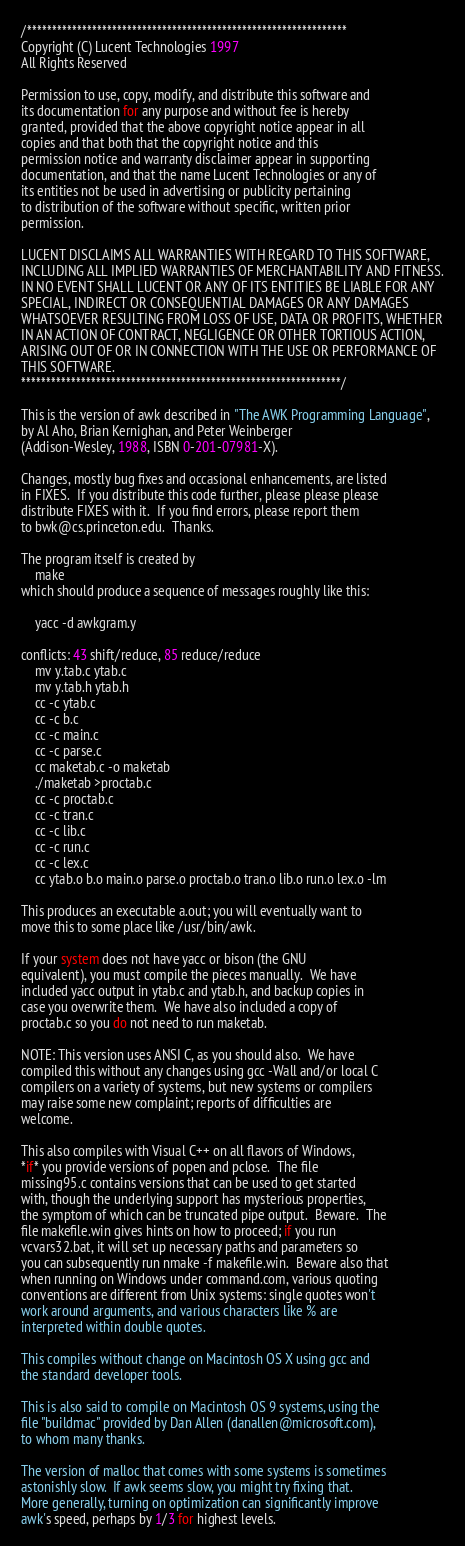<code> <loc_0><loc_0><loc_500><loc_500><_Awk_>/****************************************************************
Copyright (C) Lucent Technologies 1997
All Rights Reserved

Permission to use, copy, modify, and distribute this software and
its documentation for any purpose and without fee is hereby
granted, provided that the above copyright notice appear in all
copies and that both that the copyright notice and this
permission notice and warranty disclaimer appear in supporting
documentation, and that the name Lucent Technologies or any of
its entities not be used in advertising or publicity pertaining
to distribution of the software without specific, written prior
permission.

LUCENT DISCLAIMS ALL WARRANTIES WITH REGARD TO THIS SOFTWARE,
INCLUDING ALL IMPLIED WARRANTIES OF MERCHANTABILITY AND FITNESS.
IN NO EVENT SHALL LUCENT OR ANY OF ITS ENTITIES BE LIABLE FOR ANY
SPECIAL, INDIRECT OR CONSEQUENTIAL DAMAGES OR ANY DAMAGES
WHATSOEVER RESULTING FROM LOSS OF USE, DATA OR PROFITS, WHETHER
IN AN ACTION OF CONTRACT, NEGLIGENCE OR OTHER TORTIOUS ACTION,
ARISING OUT OF OR IN CONNECTION WITH THE USE OR PERFORMANCE OF
THIS SOFTWARE.
****************************************************************/

This is the version of awk described in "The AWK Programming Language",
by Al Aho, Brian Kernighan, and Peter Weinberger
(Addison-Wesley, 1988, ISBN 0-201-07981-X).

Changes, mostly bug fixes and occasional enhancements, are listed
in FIXES.  If you distribute this code further, please please please
distribute FIXES with it.  If you find errors, please report them
to bwk@cs.princeton.edu.  Thanks.

The program itself is created by
	make
which should produce a sequence of messages roughly like this:

	yacc -d awkgram.y

conflicts: 43 shift/reduce, 85 reduce/reduce
	mv y.tab.c ytab.c
	mv y.tab.h ytab.h
	cc -c ytab.c
	cc -c b.c
	cc -c main.c
	cc -c parse.c
	cc maketab.c -o maketab
	./maketab >proctab.c
	cc -c proctab.c
	cc -c tran.c
	cc -c lib.c
	cc -c run.c
	cc -c lex.c
	cc ytab.o b.o main.o parse.o proctab.o tran.o lib.o run.o lex.o -lm

This produces an executable a.out; you will eventually want to
move this to some place like /usr/bin/awk.

If your system does not have yacc or bison (the GNU
equivalent), you must compile the pieces manually.  We have
included yacc output in ytab.c and ytab.h, and backup copies in
case you overwrite them.  We have also included a copy of
proctab.c so you do not need to run maketab.

NOTE: This version uses ANSI C, as you should also.  We have
compiled this without any changes using gcc -Wall and/or local C
compilers on a variety of systems, but new systems or compilers
may raise some new complaint; reports of difficulties are
welcome.

This also compiles with Visual C++ on all flavors of Windows,
*if* you provide versions of popen and pclose.  The file
missing95.c contains versions that can be used to get started
with, though the underlying support has mysterious properties,
the symptom of which can be truncated pipe output.  Beware.  The
file makefile.win gives hints on how to proceed; if you run
vcvars32.bat, it will set up necessary paths and parameters so
you can subsequently run nmake -f makefile.win.  Beware also that
when running on Windows under command.com, various quoting
conventions are different from Unix systems: single quotes won't
work around arguments, and various characters like % are
interpreted within double quotes.

This compiles without change on Macintosh OS X using gcc and
the standard developer tools.

This is also said to compile on Macintosh OS 9 systems, using the
file "buildmac" provided by Dan Allen (danallen@microsoft.com),
to whom many thanks.

The version of malloc that comes with some systems is sometimes
astonishly slow.  If awk seems slow, you might try fixing that.
More generally, turning on optimization can significantly improve
awk's speed, perhaps by 1/3 for highest levels.
</code> 